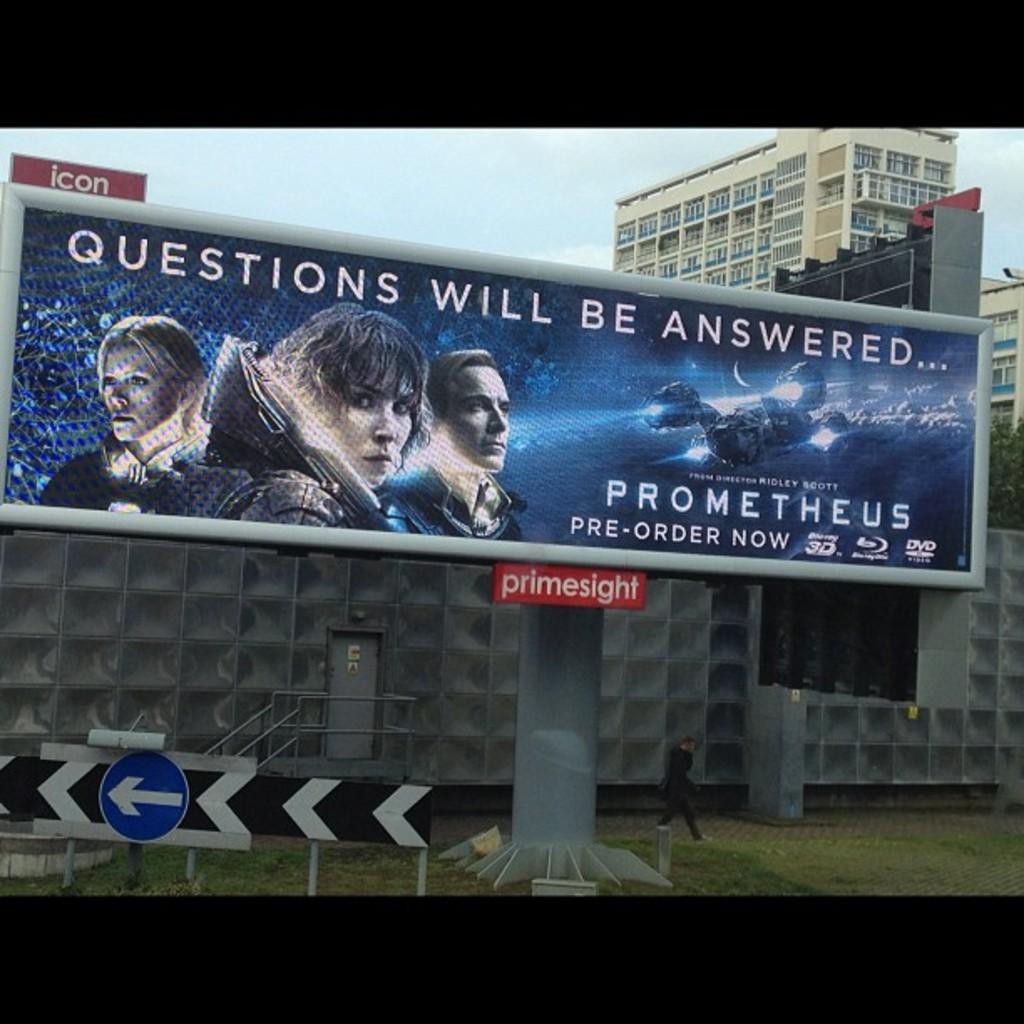Provide a one-sentence caption for the provided image. A billboard advertising the movie Prometheus, claiming questions will be answered. 